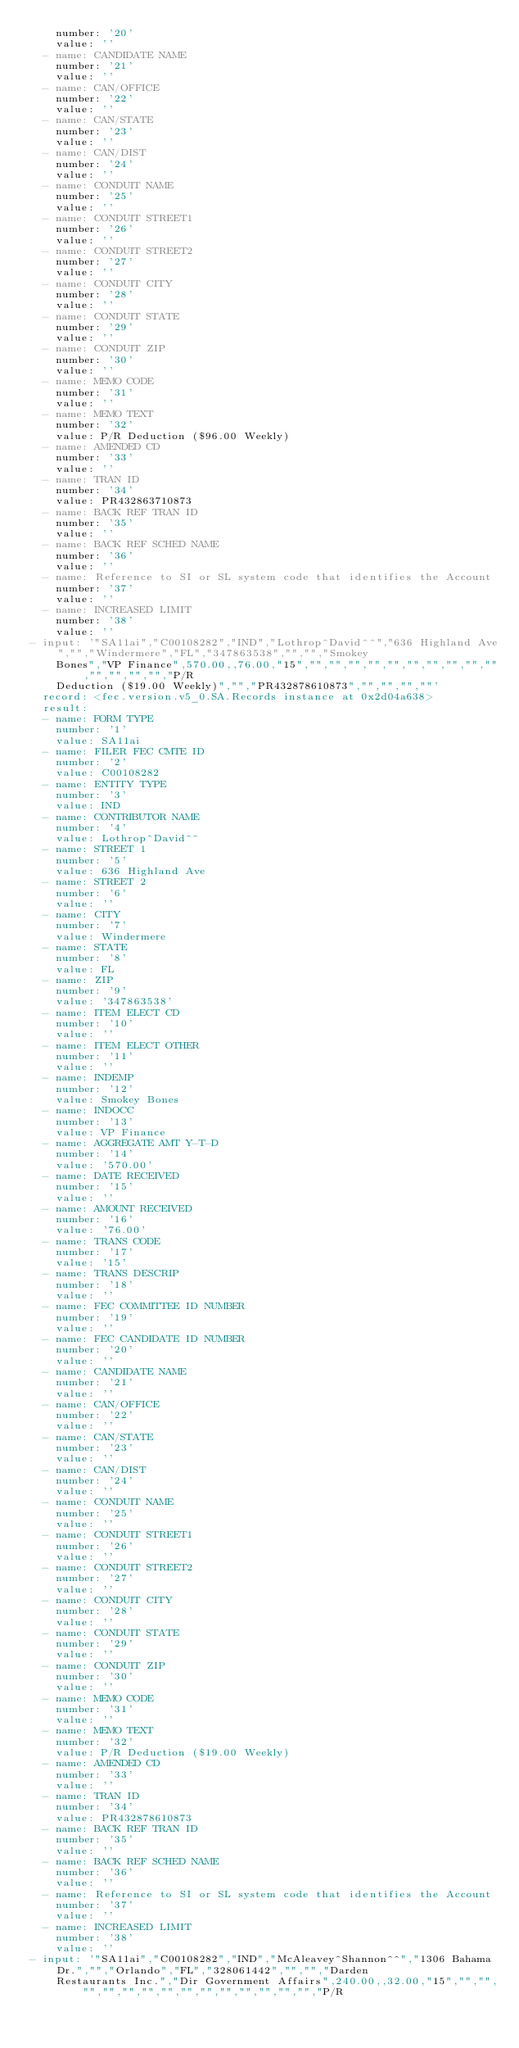<code> <loc_0><loc_0><loc_500><loc_500><_YAML_>    number: '20'
    value: ''
  - name: CANDIDATE NAME
    number: '21'
    value: ''
  - name: CAN/OFFICE
    number: '22'
    value: ''
  - name: CAN/STATE
    number: '23'
    value: ''
  - name: CAN/DIST
    number: '24'
    value: ''
  - name: CONDUIT NAME
    number: '25'
    value: ''
  - name: CONDUIT STREET1
    number: '26'
    value: ''
  - name: CONDUIT STREET2
    number: '27'
    value: ''
  - name: CONDUIT CITY
    number: '28'
    value: ''
  - name: CONDUIT STATE
    number: '29'
    value: ''
  - name: CONDUIT ZIP
    number: '30'
    value: ''
  - name: MEMO CODE
    number: '31'
    value: ''
  - name: MEMO TEXT
    number: '32'
    value: P/R Deduction ($96.00 Weekly)
  - name: AMENDED CD
    number: '33'
    value: ''
  - name: TRAN ID
    number: '34'
    value: PR432863710873
  - name: BACK REF TRAN ID
    number: '35'
    value: ''
  - name: BACK REF SCHED NAME
    number: '36'
    value: ''
  - name: Reference to SI or SL system code that identifies the Account
    number: '37'
    value: ''
  - name: INCREASED LIMIT
    number: '38'
    value: ''
- input: '"SA11ai","C00108282","IND","Lothrop^David^^","636 Highland Ave","","Windermere","FL","347863538","","","Smokey
    Bones","VP Finance",570.00,,76.00,"15","","","","","","","","","","","","","","","P/R
    Deduction ($19.00 Weekly)","","PR432878610873","","","",""'
  record: <fec.version.v5_0.SA.Records instance at 0x2d04a638>
  result:
  - name: FORM TYPE
    number: '1'
    value: SA11ai
  - name: FILER FEC CMTE ID
    number: '2'
    value: C00108282
  - name: ENTITY TYPE
    number: '3'
    value: IND
  - name: CONTRIBUTOR NAME
    number: '4'
    value: Lothrop^David^^
  - name: STREET 1
    number: '5'
    value: 636 Highland Ave
  - name: STREET 2
    number: '6'
    value: ''
  - name: CITY
    number: '7'
    value: Windermere
  - name: STATE
    number: '8'
    value: FL
  - name: ZIP
    number: '9'
    value: '347863538'
  - name: ITEM ELECT CD
    number: '10'
    value: ''
  - name: ITEM ELECT OTHER
    number: '11'
    value: ''
  - name: INDEMP
    number: '12'
    value: Smokey Bones
  - name: INDOCC
    number: '13'
    value: VP Finance
  - name: AGGREGATE AMT Y-T-D
    number: '14'
    value: '570.00'
  - name: DATE RECEIVED
    number: '15'
    value: ''
  - name: AMOUNT RECEIVED
    number: '16'
    value: '76.00'
  - name: TRANS CODE
    number: '17'
    value: '15'
  - name: TRANS DESCRIP
    number: '18'
    value: ''
  - name: FEC COMMITTEE ID NUMBER
    number: '19'
    value: ''
  - name: FEC CANDIDATE ID NUMBER
    number: '20'
    value: ''
  - name: CANDIDATE NAME
    number: '21'
    value: ''
  - name: CAN/OFFICE
    number: '22'
    value: ''
  - name: CAN/STATE
    number: '23'
    value: ''
  - name: CAN/DIST
    number: '24'
    value: ''
  - name: CONDUIT NAME
    number: '25'
    value: ''
  - name: CONDUIT STREET1
    number: '26'
    value: ''
  - name: CONDUIT STREET2
    number: '27'
    value: ''
  - name: CONDUIT CITY
    number: '28'
    value: ''
  - name: CONDUIT STATE
    number: '29'
    value: ''
  - name: CONDUIT ZIP
    number: '30'
    value: ''
  - name: MEMO CODE
    number: '31'
    value: ''
  - name: MEMO TEXT
    number: '32'
    value: P/R Deduction ($19.00 Weekly)
  - name: AMENDED CD
    number: '33'
    value: ''
  - name: TRAN ID
    number: '34'
    value: PR432878610873
  - name: BACK REF TRAN ID
    number: '35'
    value: ''
  - name: BACK REF SCHED NAME
    number: '36'
    value: ''
  - name: Reference to SI or SL system code that identifies the Account
    number: '37'
    value: ''
  - name: INCREASED LIMIT
    number: '38'
    value: ''
- input: '"SA11ai","C00108282","IND","McAleavey^Shannon^^","1306 Bahama Dr.","","Orlando","FL","328061442","","","Darden
    Restaurants Inc.","Dir Government Affairs",240.00,,32.00,"15","","","","","","","","","","","","","","","P/R</code> 